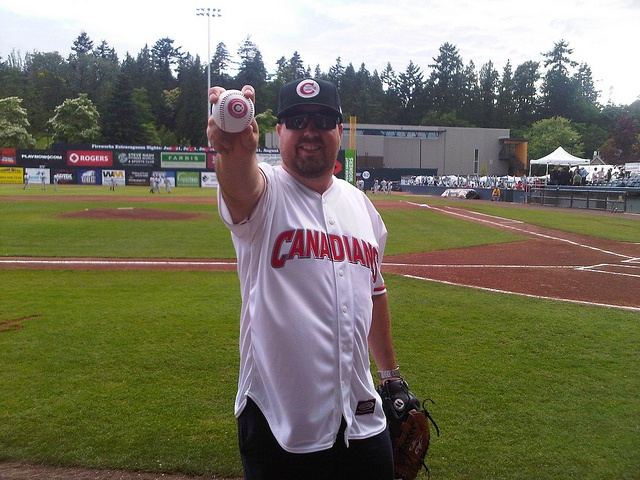Describe the objects in this image and their specific colors. I can see people in white, black, darkgray, gray, and maroon tones, people in white, gray, black, and darkgray tones, baseball glove in white, black, gray, and darkgreen tones, sports ball in white, gray, darkgray, and lavender tones, and people in white, darkgray, gray, and black tones in this image. 